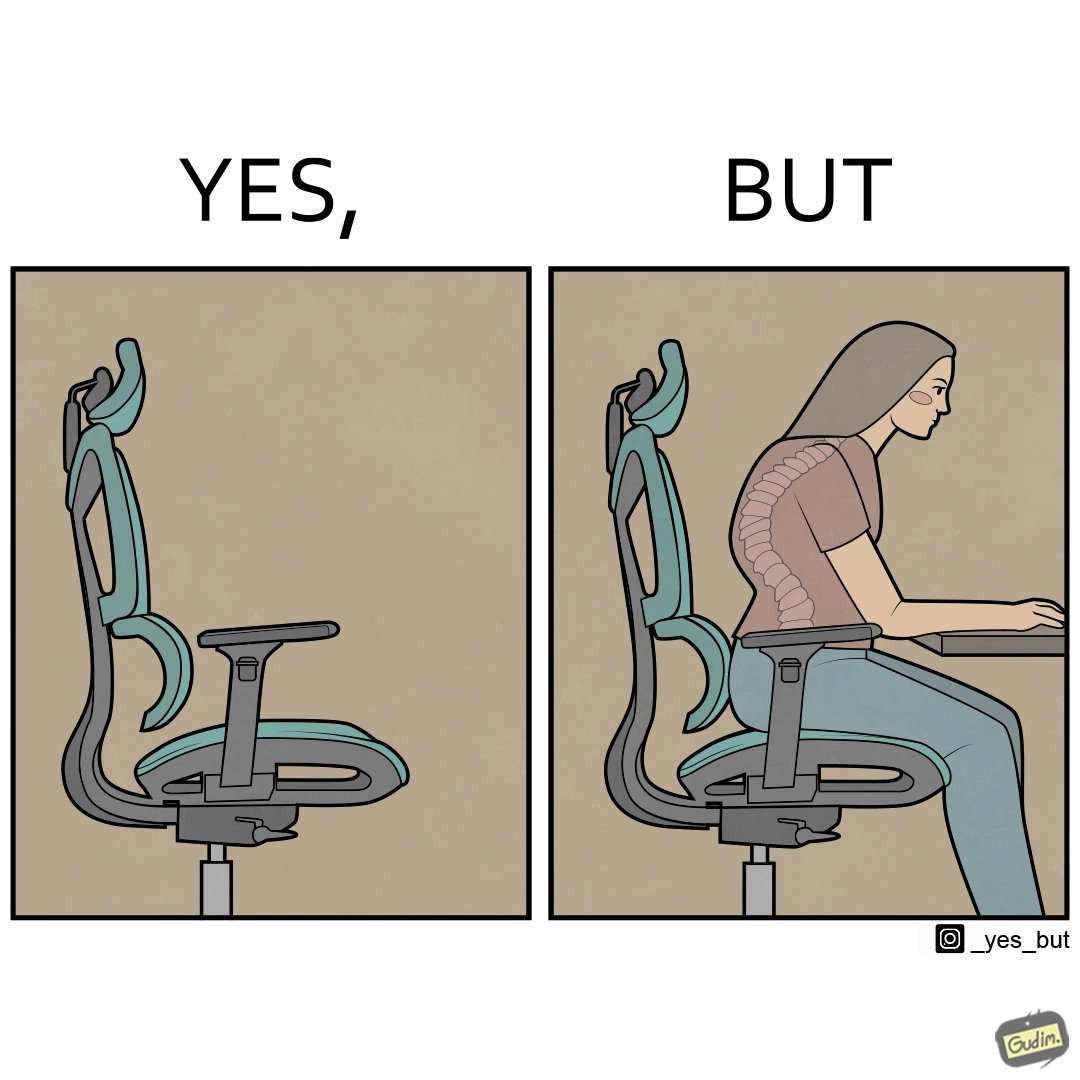Would you classify this image as satirical? Yes, this image is satirical. 